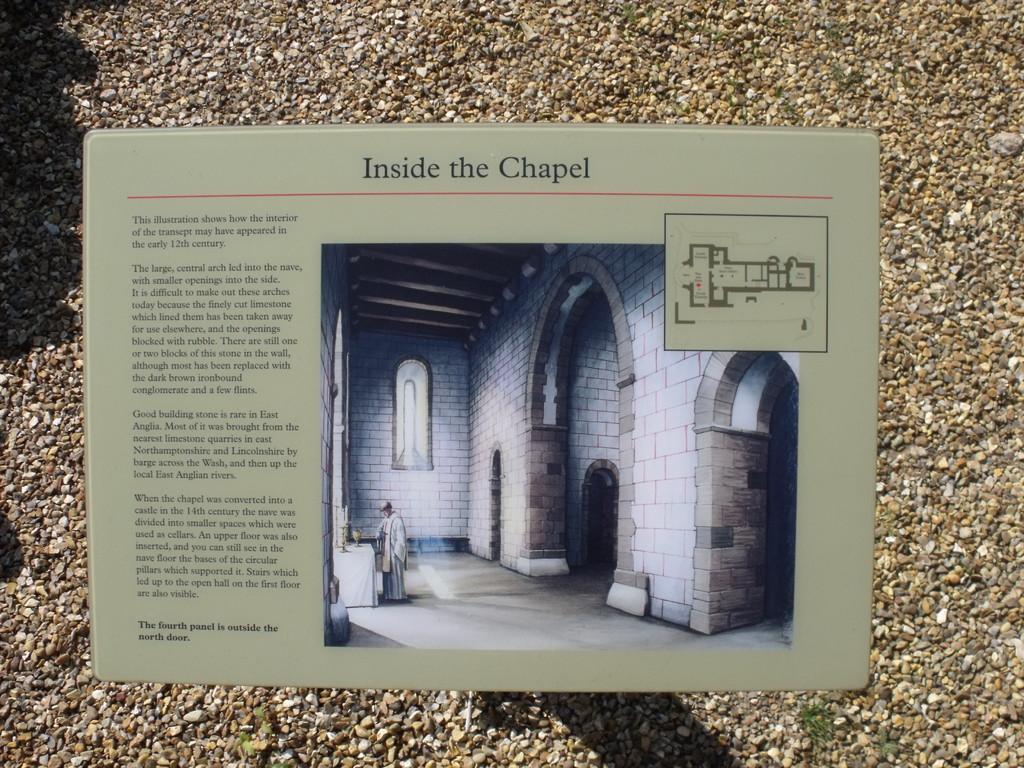Please provide a concise description of this image. In this image I can see the board. On the board I can see the text and the photo of the house. Inside the house I can see the person standing. In the background I can see many stones. 